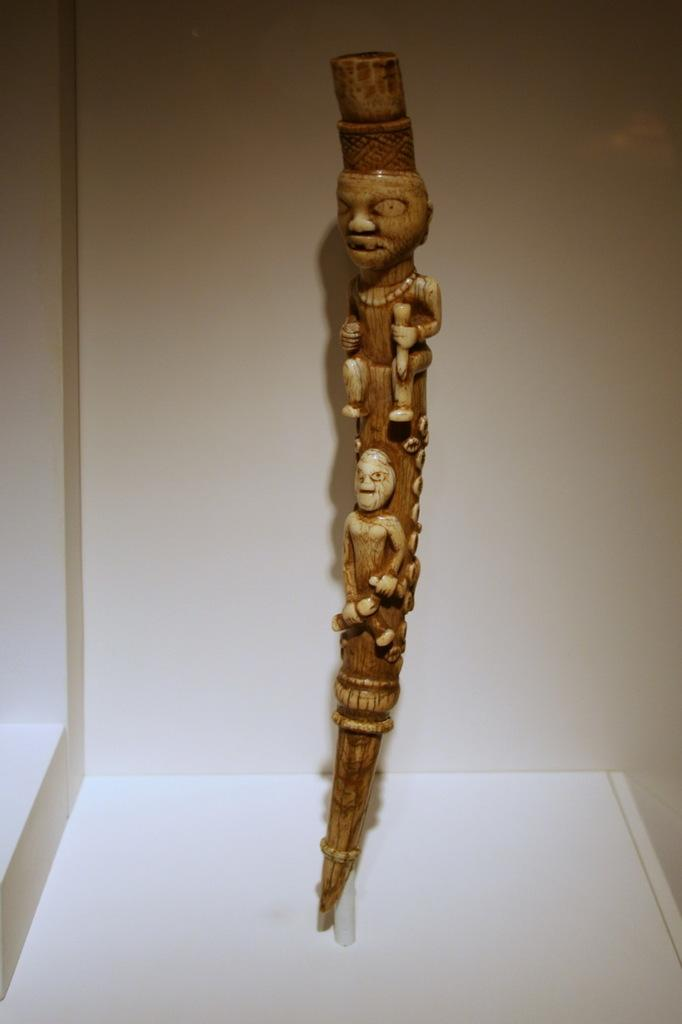What is the main subject of the image? The main subject of the image is a wooden object. Can you describe the wooden object in the image? The wooden object is carved. How is the wooden object presented in the image? The wooden object is placed in a white box. What type of wool is used to create the health benefits mentioned in the image? There is no mention of wool, health benefits, or any text in the image. The image only features a carved wooden object placed in a white box. 